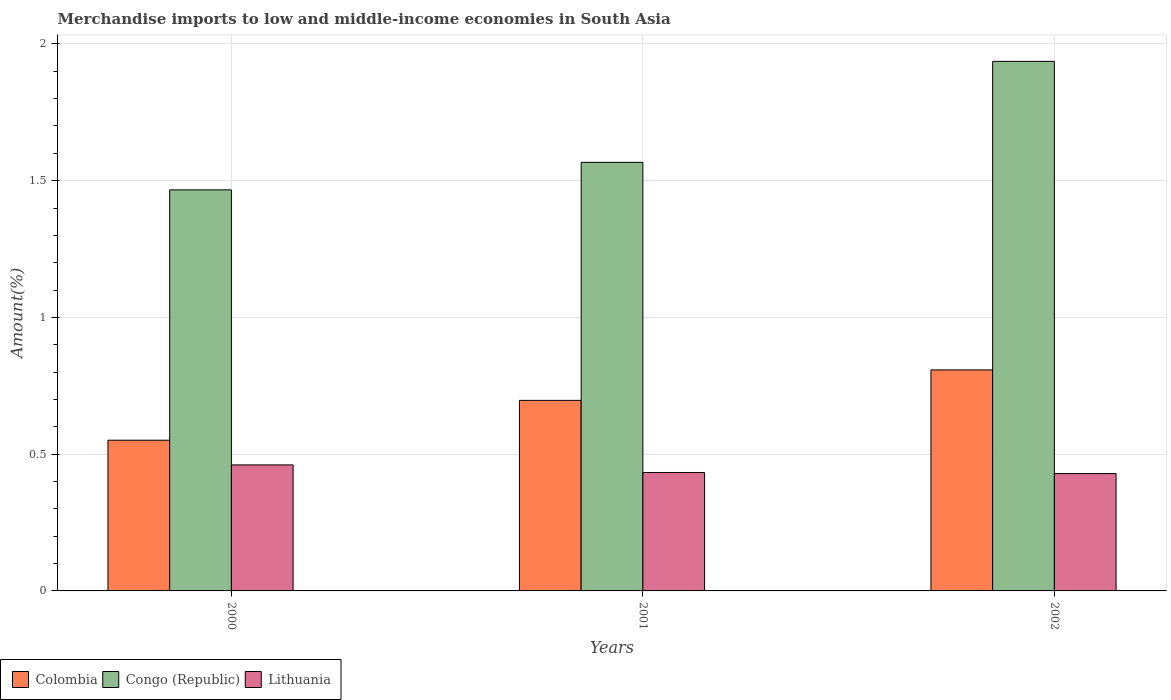How many different coloured bars are there?
Your answer should be very brief. 3. Are the number of bars on each tick of the X-axis equal?
Provide a short and direct response. Yes. How many bars are there on the 1st tick from the right?
Your response must be concise. 3. What is the label of the 1st group of bars from the left?
Keep it short and to the point. 2000. What is the percentage of amount earned from merchandise imports in Congo (Republic) in 2000?
Your response must be concise. 1.47. Across all years, what is the maximum percentage of amount earned from merchandise imports in Congo (Republic)?
Offer a terse response. 1.94. Across all years, what is the minimum percentage of amount earned from merchandise imports in Colombia?
Ensure brevity in your answer.  0.55. In which year was the percentage of amount earned from merchandise imports in Congo (Republic) minimum?
Offer a terse response. 2000. What is the total percentage of amount earned from merchandise imports in Lithuania in the graph?
Your response must be concise. 1.32. What is the difference between the percentage of amount earned from merchandise imports in Congo (Republic) in 2000 and that in 2002?
Make the answer very short. -0.47. What is the difference between the percentage of amount earned from merchandise imports in Colombia in 2000 and the percentage of amount earned from merchandise imports in Lithuania in 2001?
Provide a succinct answer. 0.12. What is the average percentage of amount earned from merchandise imports in Colombia per year?
Your response must be concise. 0.69. In the year 2000, what is the difference between the percentage of amount earned from merchandise imports in Colombia and percentage of amount earned from merchandise imports in Lithuania?
Provide a short and direct response. 0.09. What is the ratio of the percentage of amount earned from merchandise imports in Lithuania in 2000 to that in 2002?
Offer a very short reply. 1.07. What is the difference between the highest and the second highest percentage of amount earned from merchandise imports in Lithuania?
Make the answer very short. 0.03. What is the difference between the highest and the lowest percentage of amount earned from merchandise imports in Colombia?
Provide a succinct answer. 0.26. Is the sum of the percentage of amount earned from merchandise imports in Colombia in 2001 and 2002 greater than the maximum percentage of amount earned from merchandise imports in Lithuania across all years?
Keep it short and to the point. Yes. What does the 1st bar from the left in 2002 represents?
Provide a short and direct response. Colombia. What does the 1st bar from the right in 2001 represents?
Give a very brief answer. Lithuania. Is it the case that in every year, the sum of the percentage of amount earned from merchandise imports in Lithuania and percentage of amount earned from merchandise imports in Colombia is greater than the percentage of amount earned from merchandise imports in Congo (Republic)?
Give a very brief answer. No. Are all the bars in the graph horizontal?
Provide a short and direct response. No. Are the values on the major ticks of Y-axis written in scientific E-notation?
Provide a short and direct response. No. Where does the legend appear in the graph?
Your answer should be very brief. Bottom left. What is the title of the graph?
Ensure brevity in your answer.  Merchandise imports to low and middle-income economies in South Asia. What is the label or title of the Y-axis?
Make the answer very short. Amount(%). What is the Amount(%) of Colombia in 2000?
Your answer should be compact. 0.55. What is the Amount(%) of Congo (Republic) in 2000?
Keep it short and to the point. 1.47. What is the Amount(%) in Lithuania in 2000?
Keep it short and to the point. 0.46. What is the Amount(%) in Colombia in 2001?
Keep it short and to the point. 0.7. What is the Amount(%) in Congo (Republic) in 2001?
Your answer should be very brief. 1.57. What is the Amount(%) of Lithuania in 2001?
Ensure brevity in your answer.  0.43. What is the Amount(%) of Colombia in 2002?
Make the answer very short. 0.81. What is the Amount(%) of Congo (Republic) in 2002?
Your answer should be compact. 1.94. What is the Amount(%) in Lithuania in 2002?
Make the answer very short. 0.43. Across all years, what is the maximum Amount(%) in Colombia?
Your response must be concise. 0.81. Across all years, what is the maximum Amount(%) in Congo (Republic)?
Your response must be concise. 1.94. Across all years, what is the maximum Amount(%) in Lithuania?
Keep it short and to the point. 0.46. Across all years, what is the minimum Amount(%) of Colombia?
Your response must be concise. 0.55. Across all years, what is the minimum Amount(%) in Congo (Republic)?
Offer a very short reply. 1.47. Across all years, what is the minimum Amount(%) in Lithuania?
Your answer should be very brief. 0.43. What is the total Amount(%) in Colombia in the graph?
Provide a short and direct response. 2.06. What is the total Amount(%) of Congo (Republic) in the graph?
Your answer should be very brief. 4.97. What is the total Amount(%) in Lithuania in the graph?
Provide a short and direct response. 1.32. What is the difference between the Amount(%) of Colombia in 2000 and that in 2001?
Keep it short and to the point. -0.15. What is the difference between the Amount(%) of Congo (Republic) in 2000 and that in 2001?
Keep it short and to the point. -0.1. What is the difference between the Amount(%) in Lithuania in 2000 and that in 2001?
Your response must be concise. 0.03. What is the difference between the Amount(%) of Colombia in 2000 and that in 2002?
Make the answer very short. -0.26. What is the difference between the Amount(%) in Congo (Republic) in 2000 and that in 2002?
Make the answer very short. -0.47. What is the difference between the Amount(%) in Lithuania in 2000 and that in 2002?
Give a very brief answer. 0.03. What is the difference between the Amount(%) in Colombia in 2001 and that in 2002?
Your answer should be compact. -0.11. What is the difference between the Amount(%) of Congo (Republic) in 2001 and that in 2002?
Your answer should be compact. -0.37. What is the difference between the Amount(%) in Lithuania in 2001 and that in 2002?
Provide a succinct answer. 0. What is the difference between the Amount(%) in Colombia in 2000 and the Amount(%) in Congo (Republic) in 2001?
Give a very brief answer. -1.02. What is the difference between the Amount(%) of Colombia in 2000 and the Amount(%) of Lithuania in 2001?
Offer a very short reply. 0.12. What is the difference between the Amount(%) in Congo (Republic) in 2000 and the Amount(%) in Lithuania in 2001?
Offer a very short reply. 1.03. What is the difference between the Amount(%) in Colombia in 2000 and the Amount(%) in Congo (Republic) in 2002?
Offer a terse response. -1.39. What is the difference between the Amount(%) of Colombia in 2000 and the Amount(%) of Lithuania in 2002?
Your answer should be very brief. 0.12. What is the difference between the Amount(%) of Congo (Republic) in 2000 and the Amount(%) of Lithuania in 2002?
Ensure brevity in your answer.  1.04. What is the difference between the Amount(%) of Colombia in 2001 and the Amount(%) of Congo (Republic) in 2002?
Ensure brevity in your answer.  -1.24. What is the difference between the Amount(%) in Colombia in 2001 and the Amount(%) in Lithuania in 2002?
Offer a terse response. 0.27. What is the difference between the Amount(%) in Congo (Republic) in 2001 and the Amount(%) in Lithuania in 2002?
Keep it short and to the point. 1.14. What is the average Amount(%) of Colombia per year?
Your answer should be very brief. 0.69. What is the average Amount(%) in Congo (Republic) per year?
Your answer should be compact. 1.66. What is the average Amount(%) in Lithuania per year?
Provide a short and direct response. 0.44. In the year 2000, what is the difference between the Amount(%) of Colombia and Amount(%) of Congo (Republic)?
Offer a terse response. -0.92. In the year 2000, what is the difference between the Amount(%) in Colombia and Amount(%) in Lithuania?
Offer a very short reply. 0.09. In the year 2000, what is the difference between the Amount(%) of Congo (Republic) and Amount(%) of Lithuania?
Offer a terse response. 1.01. In the year 2001, what is the difference between the Amount(%) in Colombia and Amount(%) in Congo (Republic)?
Give a very brief answer. -0.87. In the year 2001, what is the difference between the Amount(%) of Colombia and Amount(%) of Lithuania?
Your response must be concise. 0.26. In the year 2001, what is the difference between the Amount(%) in Congo (Republic) and Amount(%) in Lithuania?
Provide a succinct answer. 1.13. In the year 2002, what is the difference between the Amount(%) of Colombia and Amount(%) of Congo (Republic)?
Provide a short and direct response. -1.13. In the year 2002, what is the difference between the Amount(%) of Colombia and Amount(%) of Lithuania?
Your answer should be compact. 0.38. In the year 2002, what is the difference between the Amount(%) of Congo (Republic) and Amount(%) of Lithuania?
Keep it short and to the point. 1.51. What is the ratio of the Amount(%) in Colombia in 2000 to that in 2001?
Keep it short and to the point. 0.79. What is the ratio of the Amount(%) in Congo (Republic) in 2000 to that in 2001?
Provide a short and direct response. 0.94. What is the ratio of the Amount(%) of Lithuania in 2000 to that in 2001?
Your response must be concise. 1.06. What is the ratio of the Amount(%) of Colombia in 2000 to that in 2002?
Provide a succinct answer. 0.68. What is the ratio of the Amount(%) of Congo (Republic) in 2000 to that in 2002?
Provide a short and direct response. 0.76. What is the ratio of the Amount(%) in Lithuania in 2000 to that in 2002?
Offer a very short reply. 1.07. What is the ratio of the Amount(%) of Colombia in 2001 to that in 2002?
Provide a short and direct response. 0.86. What is the ratio of the Amount(%) of Congo (Republic) in 2001 to that in 2002?
Offer a very short reply. 0.81. What is the ratio of the Amount(%) in Lithuania in 2001 to that in 2002?
Your answer should be very brief. 1.01. What is the difference between the highest and the second highest Amount(%) of Colombia?
Your answer should be compact. 0.11. What is the difference between the highest and the second highest Amount(%) of Congo (Republic)?
Offer a terse response. 0.37. What is the difference between the highest and the second highest Amount(%) of Lithuania?
Offer a very short reply. 0.03. What is the difference between the highest and the lowest Amount(%) of Colombia?
Give a very brief answer. 0.26. What is the difference between the highest and the lowest Amount(%) of Congo (Republic)?
Offer a terse response. 0.47. What is the difference between the highest and the lowest Amount(%) in Lithuania?
Offer a very short reply. 0.03. 